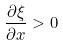<formula> <loc_0><loc_0><loc_500><loc_500>\frac { \partial \xi } { \partial x } > 0</formula> 